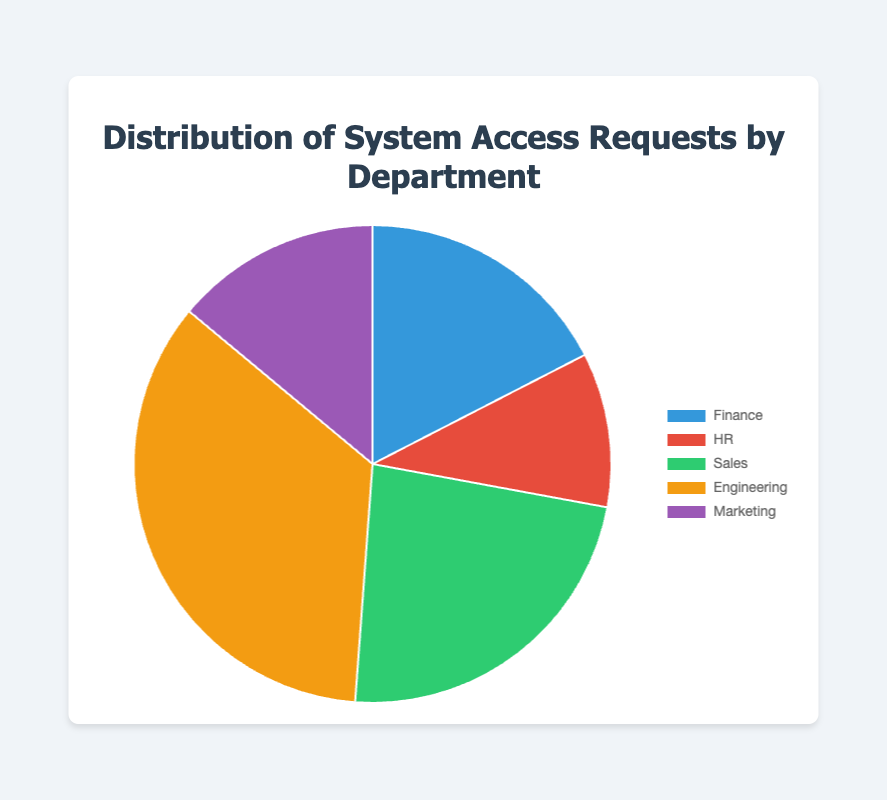What department has the highest number of system access requests? Examine the pie chart to identify the department with the largest slice. The "Engineering" slice is the largest, indicating it has the highest number of requests.
Answer: Engineering How many more requests did Sales have compared to Marketing? Identify the number of requests for Sales (200) and Marketing (120) from the pie chart. Calculate the difference: 200 - 120 = 80.
Answer: 80 What is the total number of system access requests from all departments? Sum the number of requests from each department: 150 (Finance) + 90 (HR) + 200 (Sales) + 300 (Engineering) + 120 (Marketing). The total is 860.
Answer: 860 Which department has the smallest number of system access requests? Find the smallest slice in the pie chart, which belongs to "HR" with 90 requests.
Answer: HR What percentage of the total does the Marketing department's requests represent? Divide Marketing's requests (120) by the total requests (860), then multiply by 100 to get the percentage: (120 / 860) * 100 ≈ 13.95%.
Answer: 13.95% Compare the number of requests from Finance and HR. Which department had more requests? Compare the slices representing Finance (150 requests) and HR (90 requests). Finance had more requests.
Answer: Finance How many requests did the Finance, HR, and Marketing departments have combined? Add the requests from these departments: 150 (Finance) + 90 (HR) + 120 (Marketing) = 360.
Answer: 360 What is the difference in requests between the department with the most requests and the one with the least? Identify the highest (Engineering, 300 requests) and lowest (HR, 90 requests) number of requests. Subtract the smallest from the largest: 300 - 90 = 210.
Answer: 210 What fraction of the total requests does the Sales department represent? Divide the Sales requests (200) by the total requests (860) to find the fraction: 200 / 860 ≈ 0.232.
Answer: 0.232 If you were to combine the requests from Finance and Sales, what portion of the total requests would this represent? Add the requests from Finance (150) and Sales (200) to get 350. Divide this by the total requests (860) to find the portion: 350 / 860 ≈ 0.407.
Answer: 0.407 